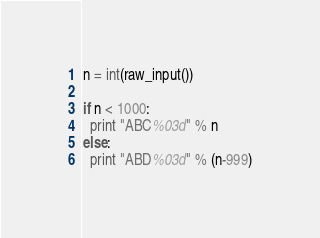<code> <loc_0><loc_0><loc_500><loc_500><_Python_>n = int(raw_input())

if n < 1000:
  print "ABC%03d" % n
else:
  print "ABD%03d" % (n-999)</code> 